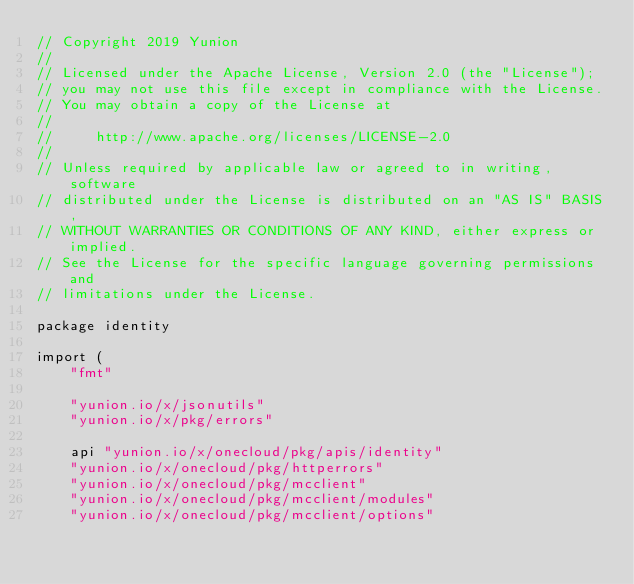Convert code to text. <code><loc_0><loc_0><loc_500><loc_500><_Go_>// Copyright 2019 Yunion
//
// Licensed under the Apache License, Version 2.0 (the "License");
// you may not use this file except in compliance with the License.
// You may obtain a copy of the License at
//
//     http://www.apache.org/licenses/LICENSE-2.0
//
// Unless required by applicable law or agreed to in writing, software
// distributed under the License is distributed on an "AS IS" BASIS,
// WITHOUT WARRANTIES OR CONDITIONS OF ANY KIND, either express or implied.
// See the License for the specific language governing permissions and
// limitations under the License.

package identity

import (
	"fmt"

	"yunion.io/x/jsonutils"
	"yunion.io/x/pkg/errors"

	api "yunion.io/x/onecloud/pkg/apis/identity"
	"yunion.io/x/onecloud/pkg/httperrors"
	"yunion.io/x/onecloud/pkg/mcclient"
	"yunion.io/x/onecloud/pkg/mcclient/modules"
	"yunion.io/x/onecloud/pkg/mcclient/options"</code> 